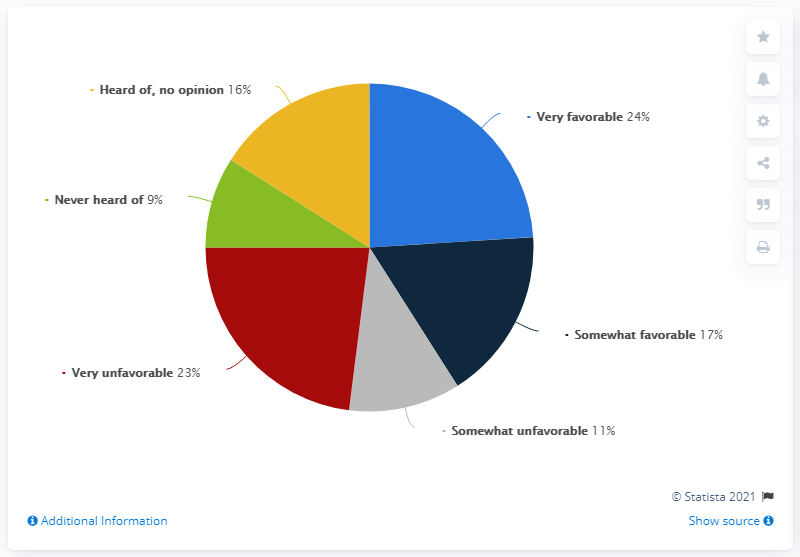Mention a couple of crucial points in this snapshot. I have never heard of Green indicating anything, and therefore I am unclear as to what it signifies. The ratio of "very favorable" to "heard of" is approximately 1.4375. 